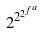<formula> <loc_0><loc_0><loc_500><loc_500>2 ^ { 2 ^ { 2 ^ { f ^ { a } } } }</formula> 